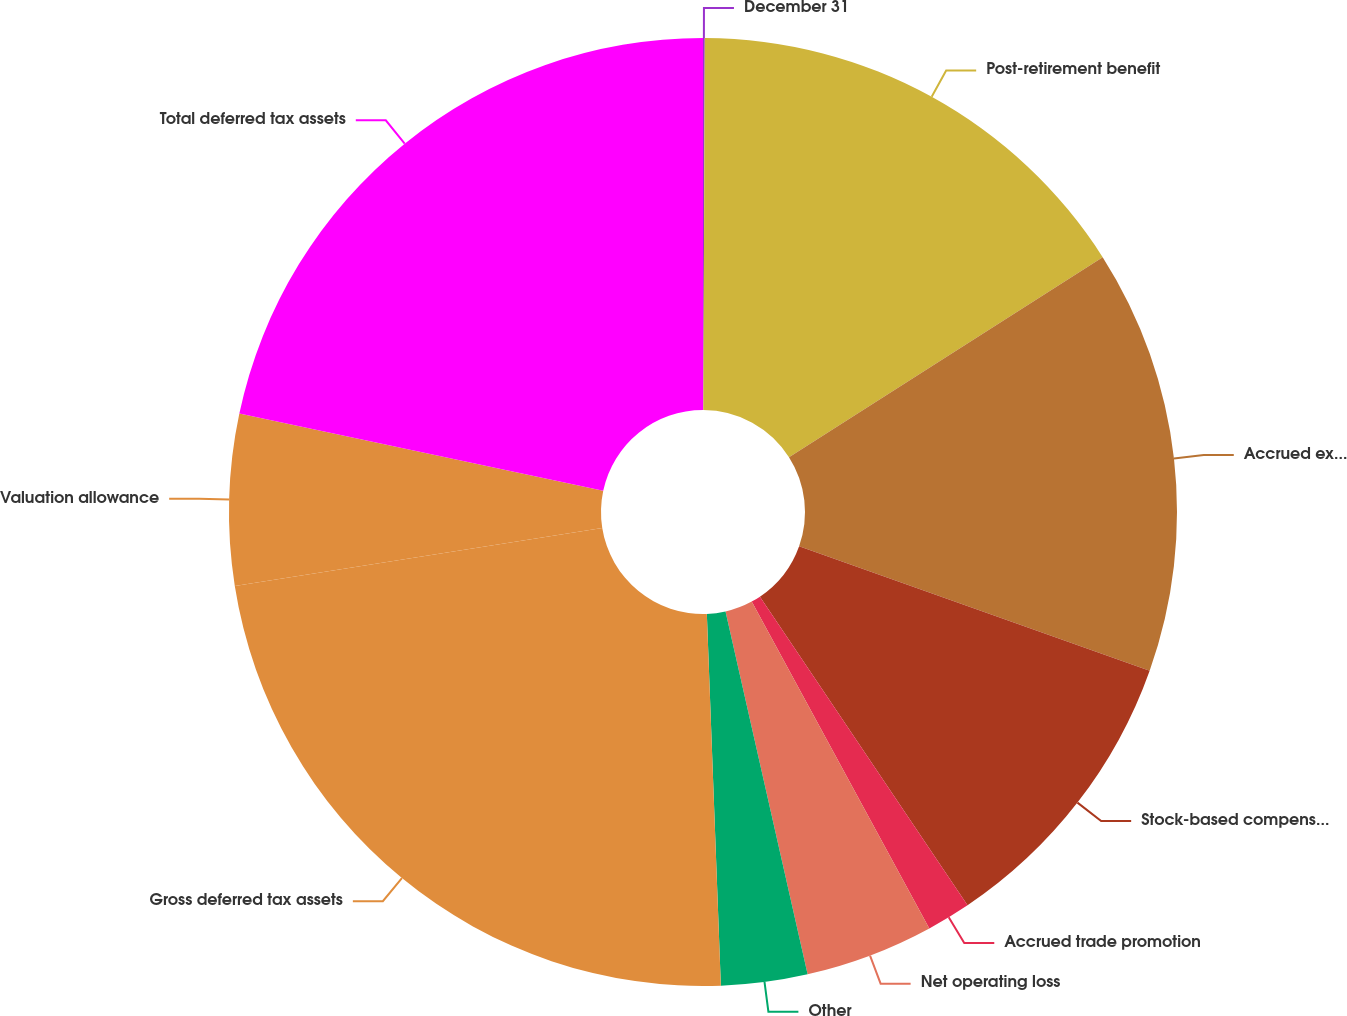Convert chart to OTSL. <chart><loc_0><loc_0><loc_500><loc_500><pie_chart><fcel>December 31<fcel>Post-retirement benefit<fcel>Accrued expenses and other<fcel>Stock-based compensation<fcel>Accrued trade promotion<fcel>Net operating loss<fcel>Other<fcel>Gross deferred tax assets<fcel>Valuation allowance<fcel>Total deferred tax assets<nl><fcel>0.06%<fcel>15.9%<fcel>14.46%<fcel>10.14%<fcel>1.5%<fcel>4.38%<fcel>2.94%<fcel>23.1%<fcel>5.82%<fcel>21.66%<nl></chart> 